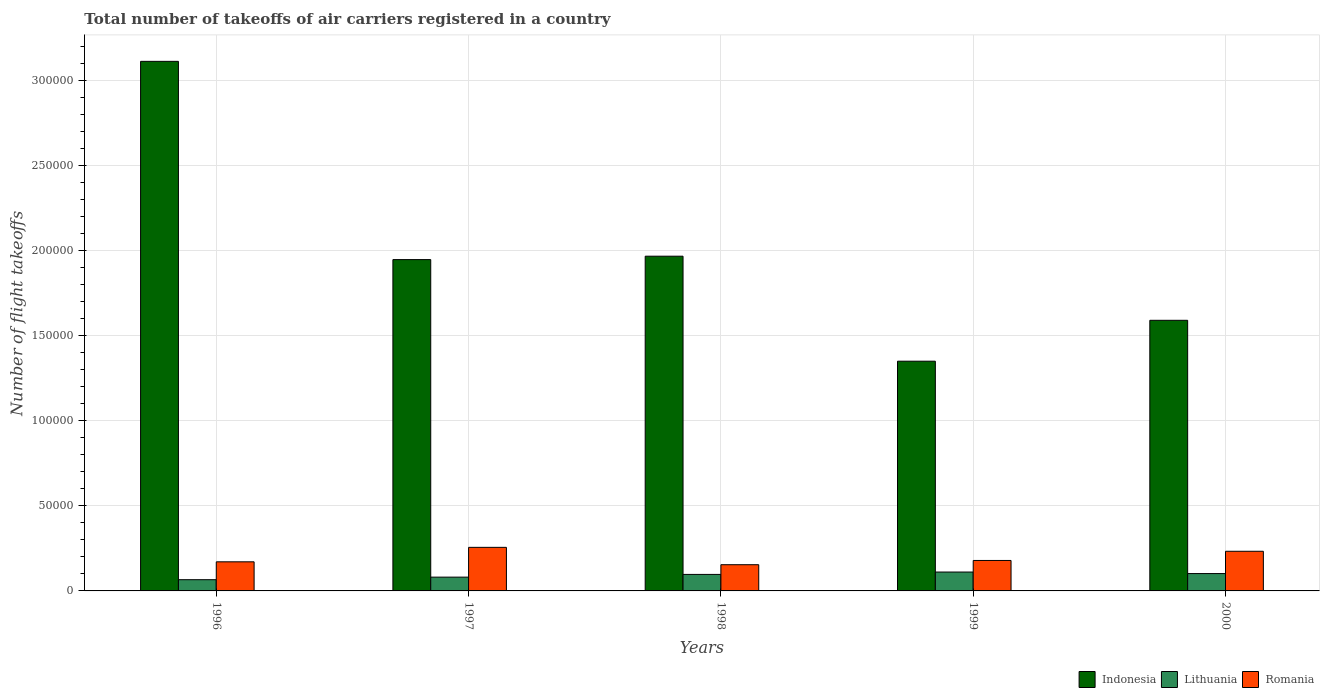How many bars are there on the 1st tick from the left?
Your answer should be very brief. 3. What is the label of the 4th group of bars from the left?
Your answer should be very brief. 1999. What is the total number of flight takeoffs in Romania in 2000?
Give a very brief answer. 2.33e+04. Across all years, what is the maximum total number of flight takeoffs in Romania?
Your answer should be very brief. 2.56e+04. Across all years, what is the minimum total number of flight takeoffs in Indonesia?
Give a very brief answer. 1.35e+05. What is the total total number of flight takeoffs in Lithuania in the graph?
Give a very brief answer. 4.57e+04. What is the difference between the total number of flight takeoffs in Lithuania in 1999 and that in 2000?
Keep it short and to the point. 903. What is the difference between the total number of flight takeoffs in Indonesia in 2000 and the total number of flight takeoffs in Romania in 1996?
Your answer should be very brief. 1.42e+05. What is the average total number of flight takeoffs in Lithuania per year?
Give a very brief answer. 9139.4. In the year 1997, what is the difference between the total number of flight takeoffs in Indonesia and total number of flight takeoffs in Lithuania?
Give a very brief answer. 1.87e+05. In how many years, is the total number of flight takeoffs in Indonesia greater than 260000?
Provide a succinct answer. 1. What is the ratio of the total number of flight takeoffs in Lithuania in 1996 to that in 1998?
Your answer should be very brief. 0.68. Is the total number of flight takeoffs in Romania in 1996 less than that in 1998?
Offer a terse response. No. What is the difference between the highest and the second highest total number of flight takeoffs in Romania?
Offer a terse response. 2302. What is the difference between the highest and the lowest total number of flight takeoffs in Lithuania?
Keep it short and to the point. 4500. In how many years, is the total number of flight takeoffs in Lithuania greater than the average total number of flight takeoffs in Lithuania taken over all years?
Your answer should be compact. 3. What does the 3rd bar from the left in 2000 represents?
Your answer should be very brief. Romania. What does the 1st bar from the right in 1997 represents?
Provide a succinct answer. Romania. How many bars are there?
Your response must be concise. 15. Are all the bars in the graph horizontal?
Your response must be concise. No. How many years are there in the graph?
Make the answer very short. 5. What is the difference between two consecutive major ticks on the Y-axis?
Offer a very short reply. 5.00e+04. Are the values on the major ticks of Y-axis written in scientific E-notation?
Keep it short and to the point. No. Where does the legend appear in the graph?
Offer a terse response. Bottom right. How are the legend labels stacked?
Give a very brief answer. Horizontal. What is the title of the graph?
Keep it short and to the point. Total number of takeoffs of air carriers registered in a country. What is the label or title of the X-axis?
Your answer should be very brief. Years. What is the label or title of the Y-axis?
Your answer should be very brief. Number of flight takeoffs. What is the Number of flight takeoffs in Indonesia in 1996?
Give a very brief answer. 3.11e+05. What is the Number of flight takeoffs of Lithuania in 1996?
Your answer should be very brief. 6600. What is the Number of flight takeoffs in Romania in 1996?
Ensure brevity in your answer.  1.71e+04. What is the Number of flight takeoffs of Indonesia in 1997?
Offer a terse response. 1.95e+05. What is the Number of flight takeoffs of Lithuania in 1997?
Your answer should be compact. 8100. What is the Number of flight takeoffs of Romania in 1997?
Your answer should be compact. 2.56e+04. What is the Number of flight takeoffs in Indonesia in 1998?
Offer a very short reply. 1.97e+05. What is the Number of flight takeoffs of Lithuania in 1998?
Keep it short and to the point. 9700. What is the Number of flight takeoffs in Romania in 1998?
Keep it short and to the point. 1.54e+04. What is the Number of flight takeoffs in Indonesia in 1999?
Ensure brevity in your answer.  1.35e+05. What is the Number of flight takeoffs of Lithuania in 1999?
Provide a succinct answer. 1.11e+04. What is the Number of flight takeoffs of Romania in 1999?
Keep it short and to the point. 1.79e+04. What is the Number of flight takeoffs in Indonesia in 2000?
Make the answer very short. 1.59e+05. What is the Number of flight takeoffs in Lithuania in 2000?
Your answer should be very brief. 1.02e+04. What is the Number of flight takeoffs of Romania in 2000?
Give a very brief answer. 2.33e+04. Across all years, what is the maximum Number of flight takeoffs in Indonesia?
Give a very brief answer. 3.11e+05. Across all years, what is the maximum Number of flight takeoffs of Lithuania?
Provide a succinct answer. 1.11e+04. Across all years, what is the maximum Number of flight takeoffs of Romania?
Your answer should be very brief. 2.56e+04. Across all years, what is the minimum Number of flight takeoffs of Indonesia?
Make the answer very short. 1.35e+05. Across all years, what is the minimum Number of flight takeoffs in Lithuania?
Your answer should be very brief. 6600. Across all years, what is the minimum Number of flight takeoffs of Romania?
Give a very brief answer. 1.54e+04. What is the total Number of flight takeoffs of Indonesia in the graph?
Your answer should be very brief. 9.97e+05. What is the total Number of flight takeoffs of Lithuania in the graph?
Your response must be concise. 4.57e+04. What is the total Number of flight takeoffs of Romania in the graph?
Provide a succinct answer. 9.93e+04. What is the difference between the Number of flight takeoffs in Indonesia in 1996 and that in 1997?
Give a very brief answer. 1.16e+05. What is the difference between the Number of flight takeoffs in Lithuania in 1996 and that in 1997?
Your answer should be very brief. -1500. What is the difference between the Number of flight takeoffs in Romania in 1996 and that in 1997?
Make the answer very short. -8500. What is the difference between the Number of flight takeoffs of Indonesia in 1996 and that in 1998?
Give a very brief answer. 1.14e+05. What is the difference between the Number of flight takeoffs in Lithuania in 1996 and that in 1998?
Offer a very short reply. -3100. What is the difference between the Number of flight takeoffs in Romania in 1996 and that in 1998?
Provide a short and direct response. 1700. What is the difference between the Number of flight takeoffs of Indonesia in 1996 and that in 1999?
Ensure brevity in your answer.  1.76e+05. What is the difference between the Number of flight takeoffs of Lithuania in 1996 and that in 1999?
Keep it short and to the point. -4500. What is the difference between the Number of flight takeoffs of Romania in 1996 and that in 1999?
Provide a succinct answer. -800. What is the difference between the Number of flight takeoffs in Indonesia in 1996 and that in 2000?
Make the answer very short. 1.52e+05. What is the difference between the Number of flight takeoffs of Lithuania in 1996 and that in 2000?
Make the answer very short. -3597. What is the difference between the Number of flight takeoffs of Romania in 1996 and that in 2000?
Your answer should be very brief. -6198. What is the difference between the Number of flight takeoffs of Indonesia in 1997 and that in 1998?
Your answer should be very brief. -2000. What is the difference between the Number of flight takeoffs of Lithuania in 1997 and that in 1998?
Give a very brief answer. -1600. What is the difference between the Number of flight takeoffs of Romania in 1997 and that in 1998?
Offer a very short reply. 1.02e+04. What is the difference between the Number of flight takeoffs in Indonesia in 1997 and that in 1999?
Offer a very short reply. 5.97e+04. What is the difference between the Number of flight takeoffs of Lithuania in 1997 and that in 1999?
Offer a terse response. -3000. What is the difference between the Number of flight takeoffs of Romania in 1997 and that in 1999?
Your response must be concise. 7700. What is the difference between the Number of flight takeoffs in Indonesia in 1997 and that in 2000?
Provide a short and direct response. 3.57e+04. What is the difference between the Number of flight takeoffs in Lithuania in 1997 and that in 2000?
Make the answer very short. -2097. What is the difference between the Number of flight takeoffs in Romania in 1997 and that in 2000?
Provide a short and direct response. 2302. What is the difference between the Number of flight takeoffs in Indonesia in 1998 and that in 1999?
Make the answer very short. 6.17e+04. What is the difference between the Number of flight takeoffs of Lithuania in 1998 and that in 1999?
Give a very brief answer. -1400. What is the difference between the Number of flight takeoffs in Romania in 1998 and that in 1999?
Provide a short and direct response. -2500. What is the difference between the Number of flight takeoffs in Indonesia in 1998 and that in 2000?
Offer a terse response. 3.77e+04. What is the difference between the Number of flight takeoffs in Lithuania in 1998 and that in 2000?
Keep it short and to the point. -497. What is the difference between the Number of flight takeoffs of Romania in 1998 and that in 2000?
Give a very brief answer. -7898. What is the difference between the Number of flight takeoffs of Indonesia in 1999 and that in 2000?
Offer a very short reply. -2.40e+04. What is the difference between the Number of flight takeoffs of Lithuania in 1999 and that in 2000?
Your answer should be compact. 903. What is the difference between the Number of flight takeoffs in Romania in 1999 and that in 2000?
Provide a succinct answer. -5398. What is the difference between the Number of flight takeoffs of Indonesia in 1996 and the Number of flight takeoffs of Lithuania in 1997?
Your answer should be very brief. 3.03e+05. What is the difference between the Number of flight takeoffs of Indonesia in 1996 and the Number of flight takeoffs of Romania in 1997?
Your answer should be very brief. 2.86e+05. What is the difference between the Number of flight takeoffs in Lithuania in 1996 and the Number of flight takeoffs in Romania in 1997?
Provide a succinct answer. -1.90e+04. What is the difference between the Number of flight takeoffs of Indonesia in 1996 and the Number of flight takeoffs of Lithuania in 1998?
Your answer should be very brief. 3.02e+05. What is the difference between the Number of flight takeoffs of Indonesia in 1996 and the Number of flight takeoffs of Romania in 1998?
Your response must be concise. 2.96e+05. What is the difference between the Number of flight takeoffs in Lithuania in 1996 and the Number of flight takeoffs in Romania in 1998?
Ensure brevity in your answer.  -8800. What is the difference between the Number of flight takeoffs in Indonesia in 1996 and the Number of flight takeoffs in Lithuania in 1999?
Give a very brief answer. 3.00e+05. What is the difference between the Number of flight takeoffs in Indonesia in 1996 and the Number of flight takeoffs in Romania in 1999?
Make the answer very short. 2.93e+05. What is the difference between the Number of flight takeoffs in Lithuania in 1996 and the Number of flight takeoffs in Romania in 1999?
Offer a very short reply. -1.13e+04. What is the difference between the Number of flight takeoffs in Indonesia in 1996 and the Number of flight takeoffs in Lithuania in 2000?
Provide a succinct answer. 3.01e+05. What is the difference between the Number of flight takeoffs in Indonesia in 1996 and the Number of flight takeoffs in Romania in 2000?
Provide a succinct answer. 2.88e+05. What is the difference between the Number of flight takeoffs of Lithuania in 1996 and the Number of flight takeoffs of Romania in 2000?
Provide a succinct answer. -1.67e+04. What is the difference between the Number of flight takeoffs of Indonesia in 1997 and the Number of flight takeoffs of Lithuania in 1998?
Offer a very short reply. 1.85e+05. What is the difference between the Number of flight takeoffs in Indonesia in 1997 and the Number of flight takeoffs in Romania in 1998?
Make the answer very short. 1.79e+05. What is the difference between the Number of flight takeoffs of Lithuania in 1997 and the Number of flight takeoffs of Romania in 1998?
Offer a very short reply. -7300. What is the difference between the Number of flight takeoffs in Indonesia in 1997 and the Number of flight takeoffs in Lithuania in 1999?
Give a very brief answer. 1.84e+05. What is the difference between the Number of flight takeoffs in Indonesia in 1997 and the Number of flight takeoffs in Romania in 1999?
Provide a succinct answer. 1.77e+05. What is the difference between the Number of flight takeoffs of Lithuania in 1997 and the Number of flight takeoffs of Romania in 1999?
Your response must be concise. -9800. What is the difference between the Number of flight takeoffs in Indonesia in 1997 and the Number of flight takeoffs in Lithuania in 2000?
Ensure brevity in your answer.  1.85e+05. What is the difference between the Number of flight takeoffs in Indonesia in 1997 and the Number of flight takeoffs in Romania in 2000?
Ensure brevity in your answer.  1.71e+05. What is the difference between the Number of flight takeoffs in Lithuania in 1997 and the Number of flight takeoffs in Romania in 2000?
Provide a succinct answer. -1.52e+04. What is the difference between the Number of flight takeoffs in Indonesia in 1998 and the Number of flight takeoffs in Lithuania in 1999?
Your answer should be compact. 1.86e+05. What is the difference between the Number of flight takeoffs in Indonesia in 1998 and the Number of flight takeoffs in Romania in 1999?
Your answer should be very brief. 1.79e+05. What is the difference between the Number of flight takeoffs of Lithuania in 1998 and the Number of flight takeoffs of Romania in 1999?
Your answer should be compact. -8200. What is the difference between the Number of flight takeoffs of Indonesia in 1998 and the Number of flight takeoffs of Lithuania in 2000?
Offer a very short reply. 1.87e+05. What is the difference between the Number of flight takeoffs in Indonesia in 1998 and the Number of flight takeoffs in Romania in 2000?
Give a very brief answer. 1.73e+05. What is the difference between the Number of flight takeoffs in Lithuania in 1998 and the Number of flight takeoffs in Romania in 2000?
Keep it short and to the point. -1.36e+04. What is the difference between the Number of flight takeoffs of Indonesia in 1999 and the Number of flight takeoffs of Lithuania in 2000?
Your response must be concise. 1.25e+05. What is the difference between the Number of flight takeoffs of Indonesia in 1999 and the Number of flight takeoffs of Romania in 2000?
Your answer should be compact. 1.12e+05. What is the difference between the Number of flight takeoffs of Lithuania in 1999 and the Number of flight takeoffs of Romania in 2000?
Keep it short and to the point. -1.22e+04. What is the average Number of flight takeoffs of Indonesia per year?
Keep it short and to the point. 1.99e+05. What is the average Number of flight takeoffs of Lithuania per year?
Keep it short and to the point. 9139.4. What is the average Number of flight takeoffs in Romania per year?
Provide a short and direct response. 1.99e+04. In the year 1996, what is the difference between the Number of flight takeoffs in Indonesia and Number of flight takeoffs in Lithuania?
Offer a very short reply. 3.05e+05. In the year 1996, what is the difference between the Number of flight takeoffs of Indonesia and Number of flight takeoffs of Romania?
Provide a succinct answer. 2.94e+05. In the year 1996, what is the difference between the Number of flight takeoffs of Lithuania and Number of flight takeoffs of Romania?
Provide a short and direct response. -1.05e+04. In the year 1997, what is the difference between the Number of flight takeoffs in Indonesia and Number of flight takeoffs in Lithuania?
Your answer should be very brief. 1.87e+05. In the year 1997, what is the difference between the Number of flight takeoffs in Indonesia and Number of flight takeoffs in Romania?
Your answer should be compact. 1.69e+05. In the year 1997, what is the difference between the Number of flight takeoffs in Lithuania and Number of flight takeoffs in Romania?
Provide a short and direct response. -1.75e+04. In the year 1998, what is the difference between the Number of flight takeoffs in Indonesia and Number of flight takeoffs in Lithuania?
Your answer should be very brief. 1.87e+05. In the year 1998, what is the difference between the Number of flight takeoffs of Indonesia and Number of flight takeoffs of Romania?
Provide a short and direct response. 1.81e+05. In the year 1998, what is the difference between the Number of flight takeoffs in Lithuania and Number of flight takeoffs in Romania?
Make the answer very short. -5700. In the year 1999, what is the difference between the Number of flight takeoffs of Indonesia and Number of flight takeoffs of Lithuania?
Give a very brief answer. 1.24e+05. In the year 1999, what is the difference between the Number of flight takeoffs of Indonesia and Number of flight takeoffs of Romania?
Your answer should be very brief. 1.17e+05. In the year 1999, what is the difference between the Number of flight takeoffs in Lithuania and Number of flight takeoffs in Romania?
Ensure brevity in your answer.  -6800. In the year 2000, what is the difference between the Number of flight takeoffs of Indonesia and Number of flight takeoffs of Lithuania?
Offer a terse response. 1.49e+05. In the year 2000, what is the difference between the Number of flight takeoffs in Indonesia and Number of flight takeoffs in Romania?
Your answer should be very brief. 1.36e+05. In the year 2000, what is the difference between the Number of flight takeoffs in Lithuania and Number of flight takeoffs in Romania?
Your answer should be compact. -1.31e+04. What is the ratio of the Number of flight takeoffs in Indonesia in 1996 to that in 1997?
Your answer should be very brief. 1.6. What is the ratio of the Number of flight takeoffs in Lithuania in 1996 to that in 1997?
Keep it short and to the point. 0.81. What is the ratio of the Number of flight takeoffs of Romania in 1996 to that in 1997?
Keep it short and to the point. 0.67. What is the ratio of the Number of flight takeoffs in Indonesia in 1996 to that in 1998?
Your answer should be compact. 1.58. What is the ratio of the Number of flight takeoffs of Lithuania in 1996 to that in 1998?
Make the answer very short. 0.68. What is the ratio of the Number of flight takeoffs of Romania in 1996 to that in 1998?
Ensure brevity in your answer.  1.11. What is the ratio of the Number of flight takeoffs in Indonesia in 1996 to that in 1999?
Your response must be concise. 2.31. What is the ratio of the Number of flight takeoffs of Lithuania in 1996 to that in 1999?
Provide a succinct answer. 0.59. What is the ratio of the Number of flight takeoffs of Romania in 1996 to that in 1999?
Ensure brevity in your answer.  0.96. What is the ratio of the Number of flight takeoffs in Indonesia in 1996 to that in 2000?
Provide a short and direct response. 1.96. What is the ratio of the Number of flight takeoffs of Lithuania in 1996 to that in 2000?
Offer a very short reply. 0.65. What is the ratio of the Number of flight takeoffs in Romania in 1996 to that in 2000?
Offer a very short reply. 0.73. What is the ratio of the Number of flight takeoffs of Lithuania in 1997 to that in 1998?
Your answer should be compact. 0.84. What is the ratio of the Number of flight takeoffs of Romania in 1997 to that in 1998?
Provide a short and direct response. 1.66. What is the ratio of the Number of flight takeoffs of Indonesia in 1997 to that in 1999?
Give a very brief answer. 1.44. What is the ratio of the Number of flight takeoffs of Lithuania in 1997 to that in 1999?
Your response must be concise. 0.73. What is the ratio of the Number of flight takeoffs in Romania in 1997 to that in 1999?
Give a very brief answer. 1.43. What is the ratio of the Number of flight takeoffs of Indonesia in 1997 to that in 2000?
Your answer should be compact. 1.22. What is the ratio of the Number of flight takeoffs of Lithuania in 1997 to that in 2000?
Provide a succinct answer. 0.79. What is the ratio of the Number of flight takeoffs of Romania in 1997 to that in 2000?
Your answer should be compact. 1.1. What is the ratio of the Number of flight takeoffs in Indonesia in 1998 to that in 1999?
Your answer should be compact. 1.46. What is the ratio of the Number of flight takeoffs in Lithuania in 1998 to that in 1999?
Make the answer very short. 0.87. What is the ratio of the Number of flight takeoffs in Romania in 1998 to that in 1999?
Offer a terse response. 0.86. What is the ratio of the Number of flight takeoffs in Indonesia in 1998 to that in 2000?
Ensure brevity in your answer.  1.24. What is the ratio of the Number of flight takeoffs of Lithuania in 1998 to that in 2000?
Give a very brief answer. 0.95. What is the ratio of the Number of flight takeoffs in Romania in 1998 to that in 2000?
Ensure brevity in your answer.  0.66. What is the ratio of the Number of flight takeoffs of Indonesia in 1999 to that in 2000?
Your answer should be compact. 0.85. What is the ratio of the Number of flight takeoffs in Lithuania in 1999 to that in 2000?
Provide a short and direct response. 1.09. What is the ratio of the Number of flight takeoffs of Romania in 1999 to that in 2000?
Keep it short and to the point. 0.77. What is the difference between the highest and the second highest Number of flight takeoffs in Indonesia?
Give a very brief answer. 1.14e+05. What is the difference between the highest and the second highest Number of flight takeoffs of Lithuania?
Ensure brevity in your answer.  903. What is the difference between the highest and the second highest Number of flight takeoffs of Romania?
Keep it short and to the point. 2302. What is the difference between the highest and the lowest Number of flight takeoffs in Indonesia?
Provide a short and direct response. 1.76e+05. What is the difference between the highest and the lowest Number of flight takeoffs of Lithuania?
Your answer should be very brief. 4500. What is the difference between the highest and the lowest Number of flight takeoffs in Romania?
Provide a short and direct response. 1.02e+04. 